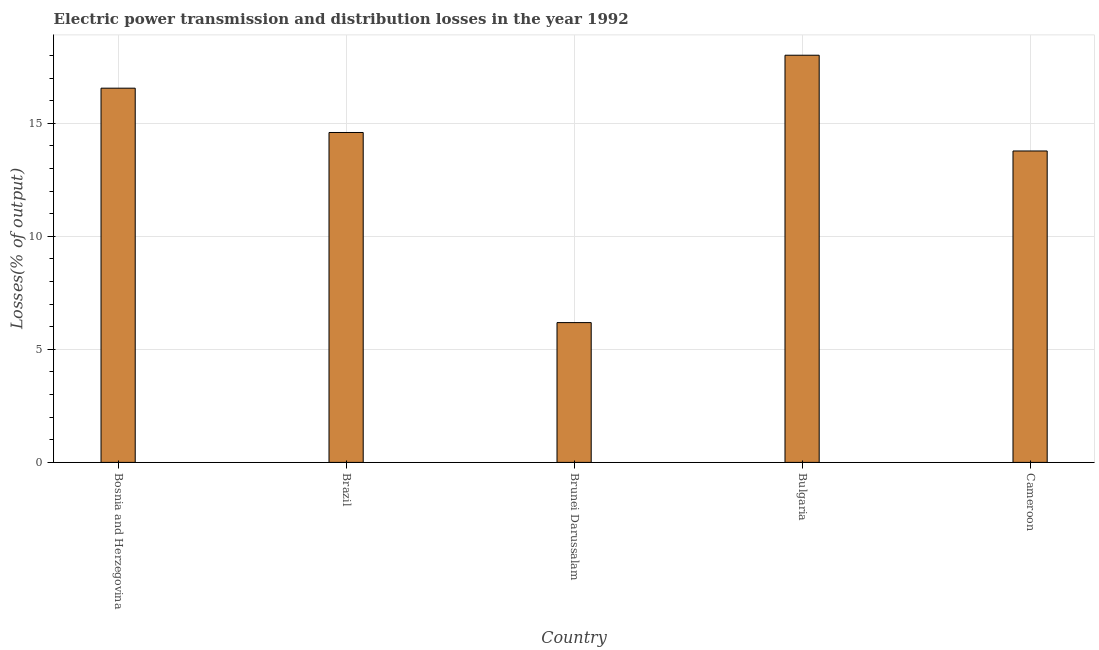Does the graph contain grids?
Offer a terse response. Yes. What is the title of the graph?
Your answer should be very brief. Electric power transmission and distribution losses in the year 1992. What is the label or title of the X-axis?
Make the answer very short. Country. What is the label or title of the Y-axis?
Your answer should be compact. Losses(% of output). What is the electric power transmission and distribution losses in Brunei Darussalam?
Offer a very short reply. 6.18. Across all countries, what is the maximum electric power transmission and distribution losses?
Provide a short and direct response. 18.01. Across all countries, what is the minimum electric power transmission and distribution losses?
Ensure brevity in your answer.  6.18. In which country was the electric power transmission and distribution losses minimum?
Provide a short and direct response. Brunei Darussalam. What is the sum of the electric power transmission and distribution losses?
Your response must be concise. 69.11. What is the difference between the electric power transmission and distribution losses in Bosnia and Herzegovina and Bulgaria?
Keep it short and to the point. -1.46. What is the average electric power transmission and distribution losses per country?
Ensure brevity in your answer.  13.82. What is the median electric power transmission and distribution losses?
Your answer should be compact. 14.59. In how many countries, is the electric power transmission and distribution losses greater than 4 %?
Your answer should be compact. 5. What is the ratio of the electric power transmission and distribution losses in Brunei Darussalam to that in Cameroon?
Offer a very short reply. 0.45. What is the difference between the highest and the second highest electric power transmission and distribution losses?
Provide a short and direct response. 1.46. What is the difference between the highest and the lowest electric power transmission and distribution losses?
Ensure brevity in your answer.  11.83. What is the difference between two consecutive major ticks on the Y-axis?
Ensure brevity in your answer.  5. Are the values on the major ticks of Y-axis written in scientific E-notation?
Your answer should be compact. No. What is the Losses(% of output) of Bosnia and Herzegovina?
Your answer should be compact. 16.55. What is the Losses(% of output) of Brazil?
Your answer should be very brief. 14.59. What is the Losses(% of output) in Brunei Darussalam?
Keep it short and to the point. 6.18. What is the Losses(% of output) in Bulgaria?
Your answer should be compact. 18.01. What is the Losses(% of output) of Cameroon?
Provide a short and direct response. 13.77. What is the difference between the Losses(% of output) in Bosnia and Herzegovina and Brazil?
Your answer should be compact. 1.96. What is the difference between the Losses(% of output) in Bosnia and Herzegovina and Brunei Darussalam?
Your response must be concise. 10.37. What is the difference between the Losses(% of output) in Bosnia and Herzegovina and Bulgaria?
Provide a succinct answer. -1.46. What is the difference between the Losses(% of output) in Bosnia and Herzegovina and Cameroon?
Your answer should be very brief. 2.78. What is the difference between the Losses(% of output) in Brazil and Brunei Darussalam?
Keep it short and to the point. 8.41. What is the difference between the Losses(% of output) in Brazil and Bulgaria?
Provide a short and direct response. -3.42. What is the difference between the Losses(% of output) in Brazil and Cameroon?
Give a very brief answer. 0.82. What is the difference between the Losses(% of output) in Brunei Darussalam and Bulgaria?
Provide a short and direct response. -11.83. What is the difference between the Losses(% of output) in Brunei Darussalam and Cameroon?
Your response must be concise. -7.59. What is the difference between the Losses(% of output) in Bulgaria and Cameroon?
Your response must be concise. 4.23. What is the ratio of the Losses(% of output) in Bosnia and Herzegovina to that in Brazil?
Offer a terse response. 1.13. What is the ratio of the Losses(% of output) in Bosnia and Herzegovina to that in Brunei Darussalam?
Your response must be concise. 2.68. What is the ratio of the Losses(% of output) in Bosnia and Herzegovina to that in Bulgaria?
Your response must be concise. 0.92. What is the ratio of the Losses(% of output) in Bosnia and Herzegovina to that in Cameroon?
Make the answer very short. 1.2. What is the ratio of the Losses(% of output) in Brazil to that in Brunei Darussalam?
Provide a short and direct response. 2.36. What is the ratio of the Losses(% of output) in Brazil to that in Bulgaria?
Provide a short and direct response. 0.81. What is the ratio of the Losses(% of output) in Brazil to that in Cameroon?
Offer a terse response. 1.06. What is the ratio of the Losses(% of output) in Brunei Darussalam to that in Bulgaria?
Your answer should be very brief. 0.34. What is the ratio of the Losses(% of output) in Brunei Darussalam to that in Cameroon?
Provide a succinct answer. 0.45. What is the ratio of the Losses(% of output) in Bulgaria to that in Cameroon?
Offer a very short reply. 1.31. 